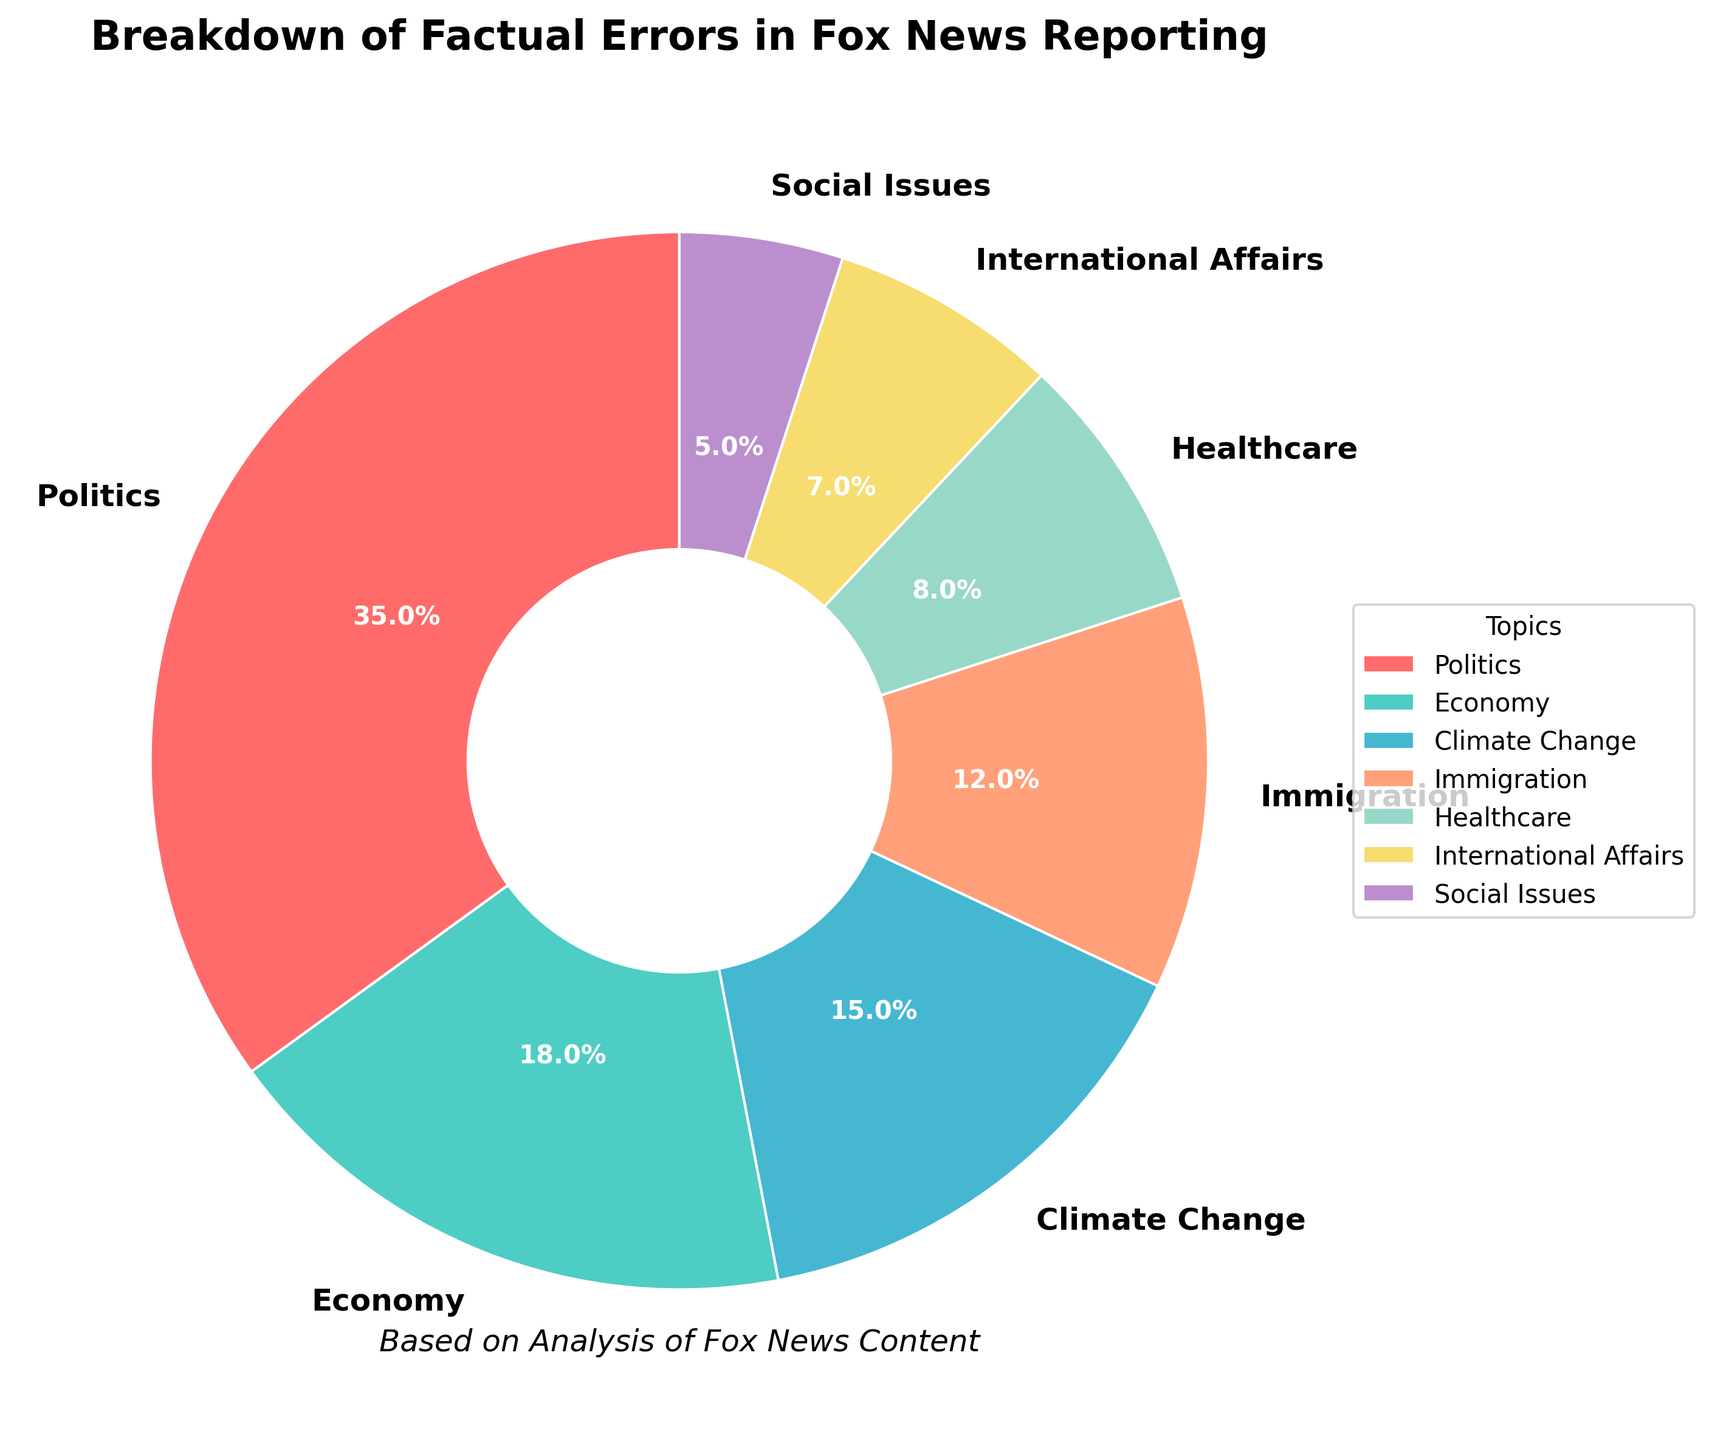What percentage of factual errors are related to Healthcare? From the pie chart, locate the slice labeled "Healthcare" and read the percentage directly.
Answer: 8% If you were to combine the percentages of factual errors in Climate Change and Immigration, what would be the total percentage? Add the percentage of factual errors in Climate Change (15%) and Immigration (12%). 15% + 12% = 27%
Answer: 27% Which topic has the highest percentage of factual errors? From the pie chart, identify the slice with the largest percentage, which is labeled "Politics" at 35%.
Answer: Politics Are the factual errors related to Social Issues less than those related to International Affairs? Compare the percentages of factual errors: Social Issues (5%) and International Affairs (7%). Since 5% is less than 7%, the answer is yes.
Answer: Yes What is the total percentage of factual errors in the top three categories combined? Add the percentages of the top three categories: Politics (35%), Economy (18%), and Climate Change (15%). 35% + 18% + 15% = 68%
Answer: 68% Which color represents the topic with 12% of factual errors? Locate the slice with 12% labeled "Immigration" and observe its color, which is orange (represented by '#FFA07A').
Answer: Orange What is the difference in percentage points between Economy and Healthcare? Subtract the percentage of Healthcare (8%) from the percentage of Economy (18%). 18% - 8% = 10%
Answer: 10% Between Social Issues and International Affairs, which has fewer factual errors and by how much? Compare the percentages of Social Issues (5%) and International Affairs (7%). Social Issues have fewer errors by 2 percentage points (7% - 5% = 2%).
Answer: Social Issues, by 2% Which two topics have almost identical percentages of factual errors and what are those percentages? Compare the percentages of all topics to find that Social Issues (5%) and International Affairs (7%) are not identical, but close in value. So the most identical would be Economy (18%) and Climate Change (15%) which are the nearest to being identical.
Answer: Economy and Climate Change are the nearest What is the combined percentage of categories with fewer than 10% factual errors? Add percentages of categories with fewer than 10%: Healthcare (8%), International Affairs (7%), and Social Issues (5%). 8% + 7% + 5% = 20%
Answer: 20% 